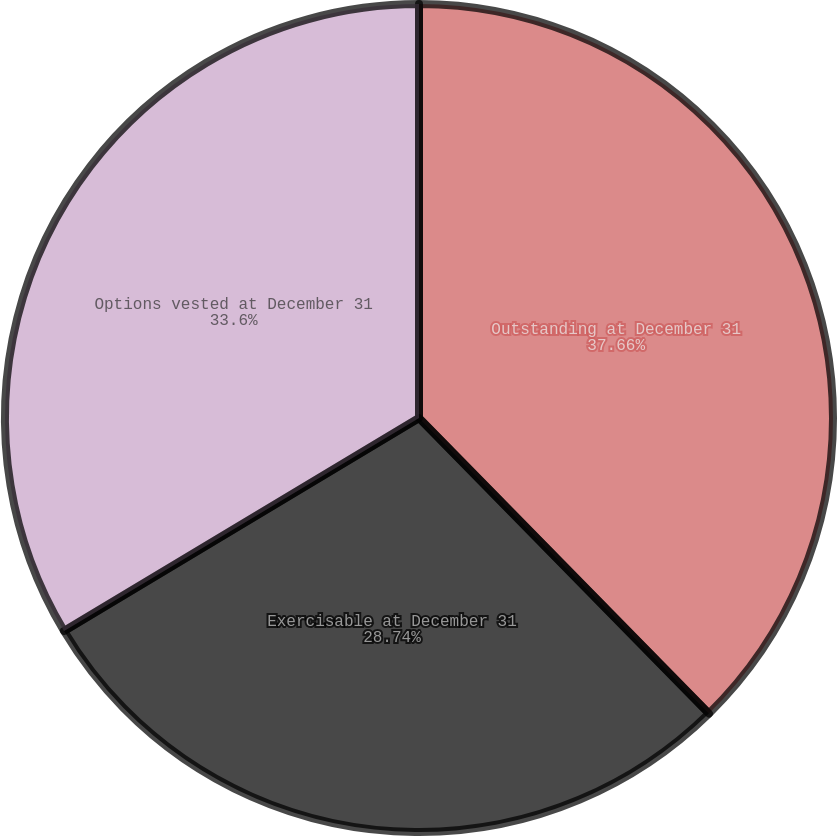Convert chart. <chart><loc_0><loc_0><loc_500><loc_500><pie_chart><fcel>Outstanding at December 31<fcel>Exercisable at December 31<fcel>Options vested at December 31<nl><fcel>37.65%<fcel>28.74%<fcel>33.6%<nl></chart> 